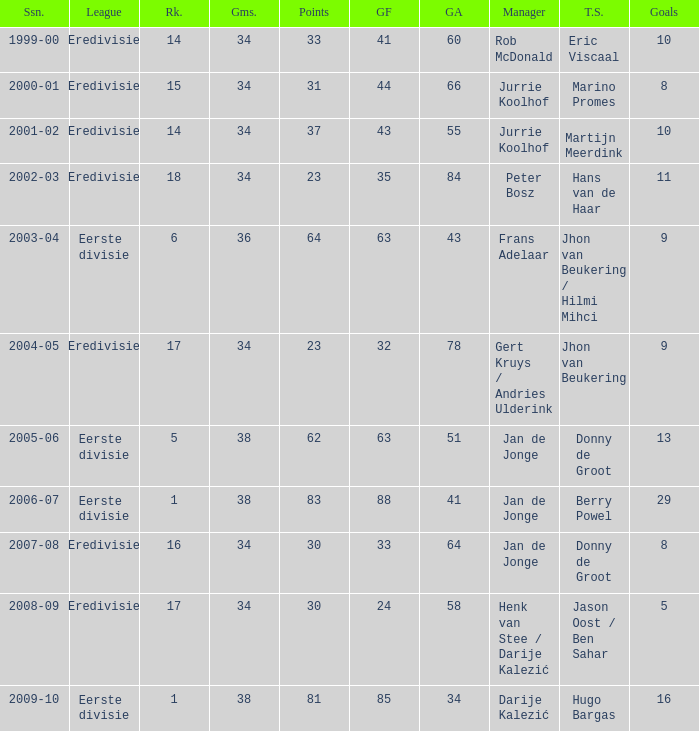How many seasons had a rank of 16? 1.0. 